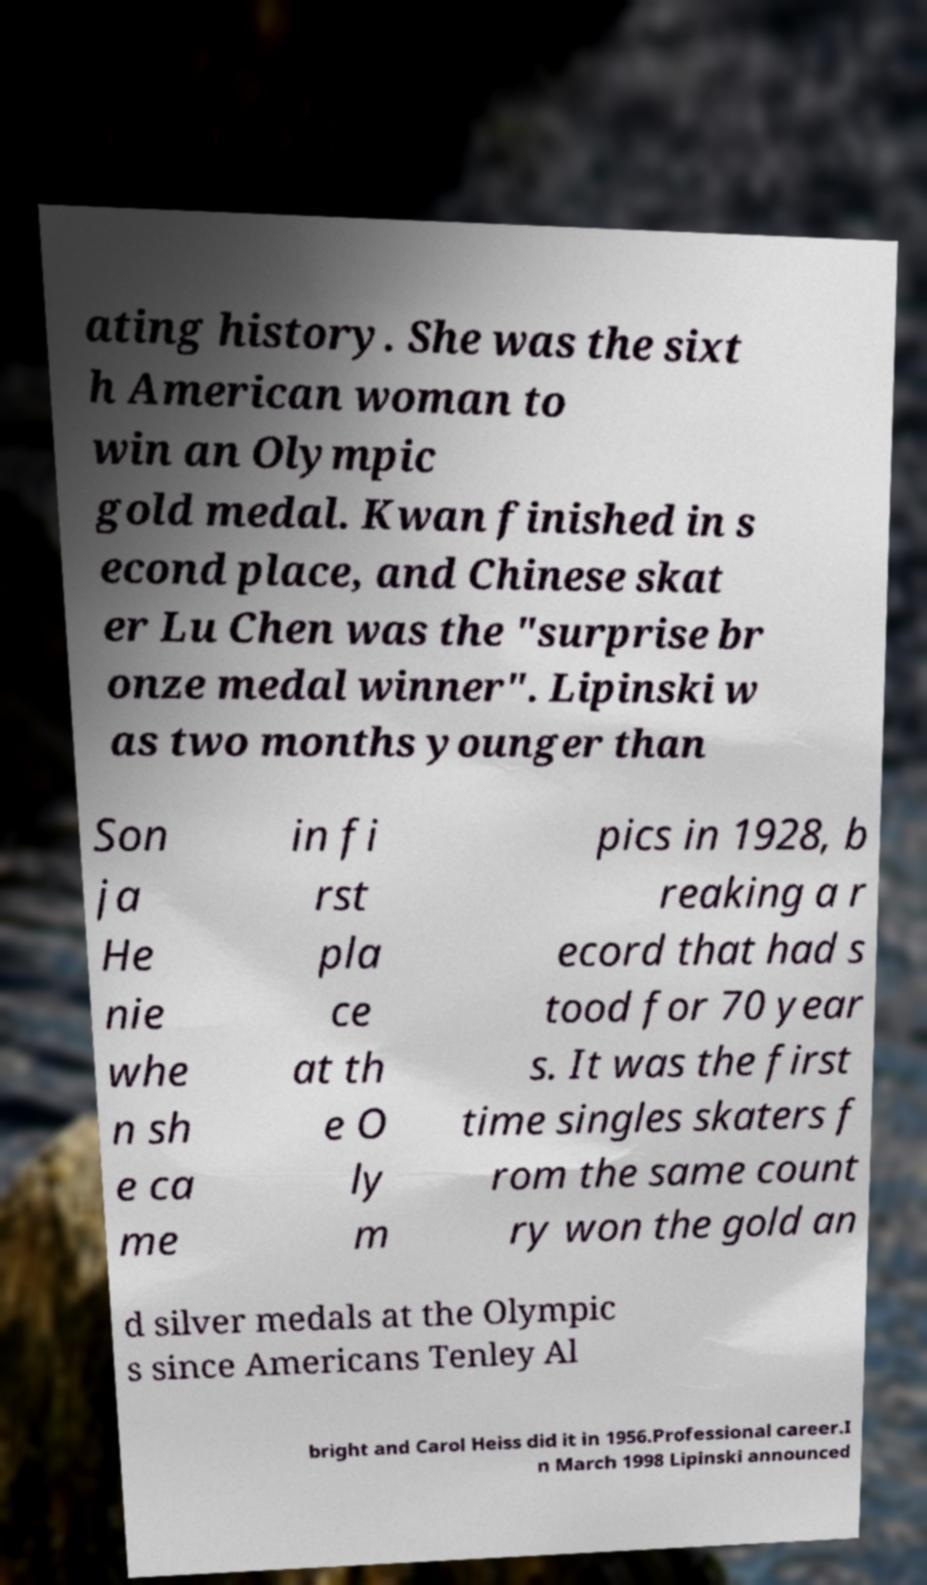Could you extract and type out the text from this image? ating history. She was the sixt h American woman to win an Olympic gold medal. Kwan finished in s econd place, and Chinese skat er Lu Chen was the "surprise br onze medal winner". Lipinski w as two months younger than Son ja He nie whe n sh e ca me in fi rst pla ce at th e O ly m pics in 1928, b reaking a r ecord that had s tood for 70 year s. It was the first time singles skaters f rom the same count ry won the gold an d silver medals at the Olympic s since Americans Tenley Al bright and Carol Heiss did it in 1956.Professional career.I n March 1998 Lipinski announced 